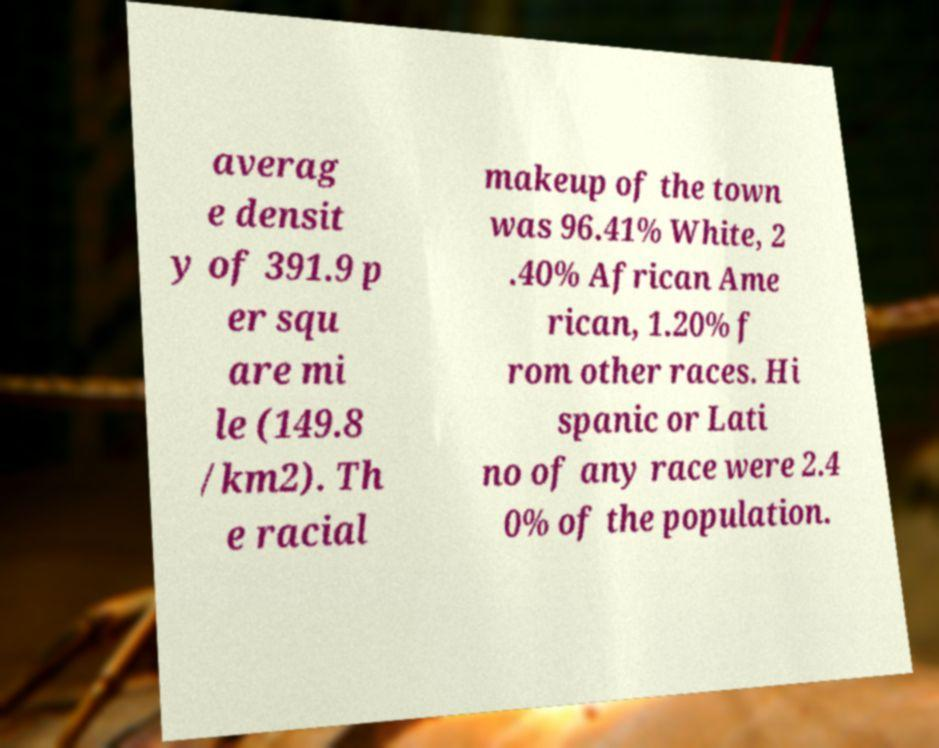Can you read and provide the text displayed in the image?This photo seems to have some interesting text. Can you extract and type it out for me? averag e densit y of 391.9 p er squ are mi le (149.8 /km2). Th e racial makeup of the town was 96.41% White, 2 .40% African Ame rican, 1.20% f rom other races. Hi spanic or Lati no of any race were 2.4 0% of the population. 